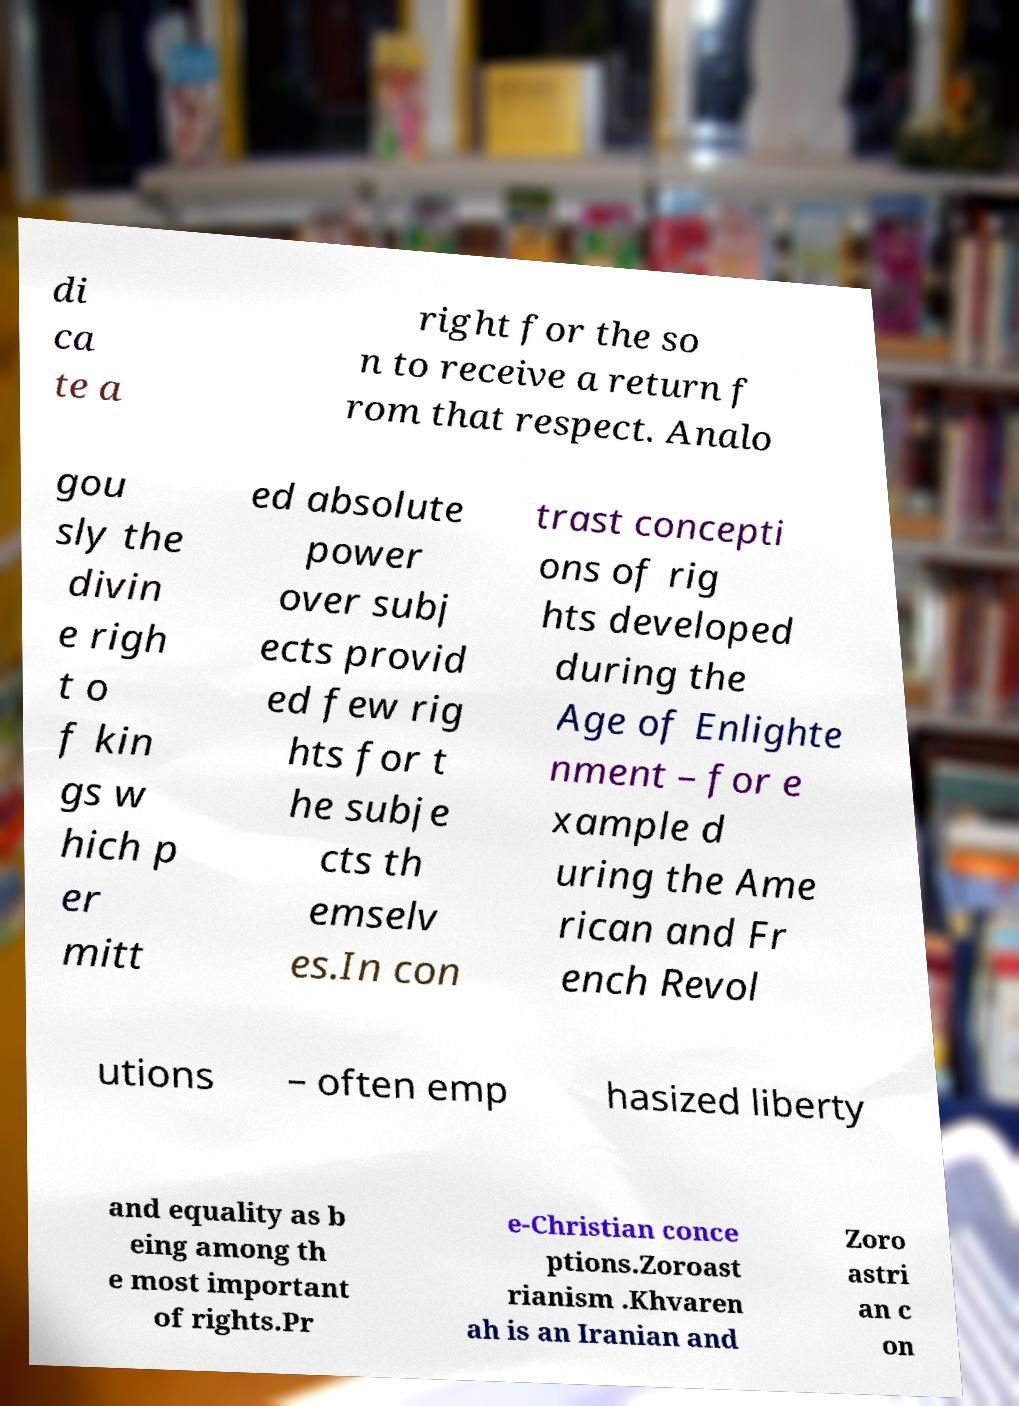Could you assist in decoding the text presented in this image and type it out clearly? di ca te a right for the so n to receive a return f rom that respect. Analo gou sly the divin e righ t o f kin gs w hich p er mitt ed absolute power over subj ects provid ed few rig hts for t he subje cts th emselv es.In con trast concepti ons of rig hts developed during the Age of Enlighte nment – for e xample d uring the Ame rican and Fr ench Revol utions – often emp hasized liberty and equality as b eing among th e most important of rights.Pr e-Christian conce ptions.Zoroast rianism .Khvaren ah is an Iranian and Zoro astri an c on 